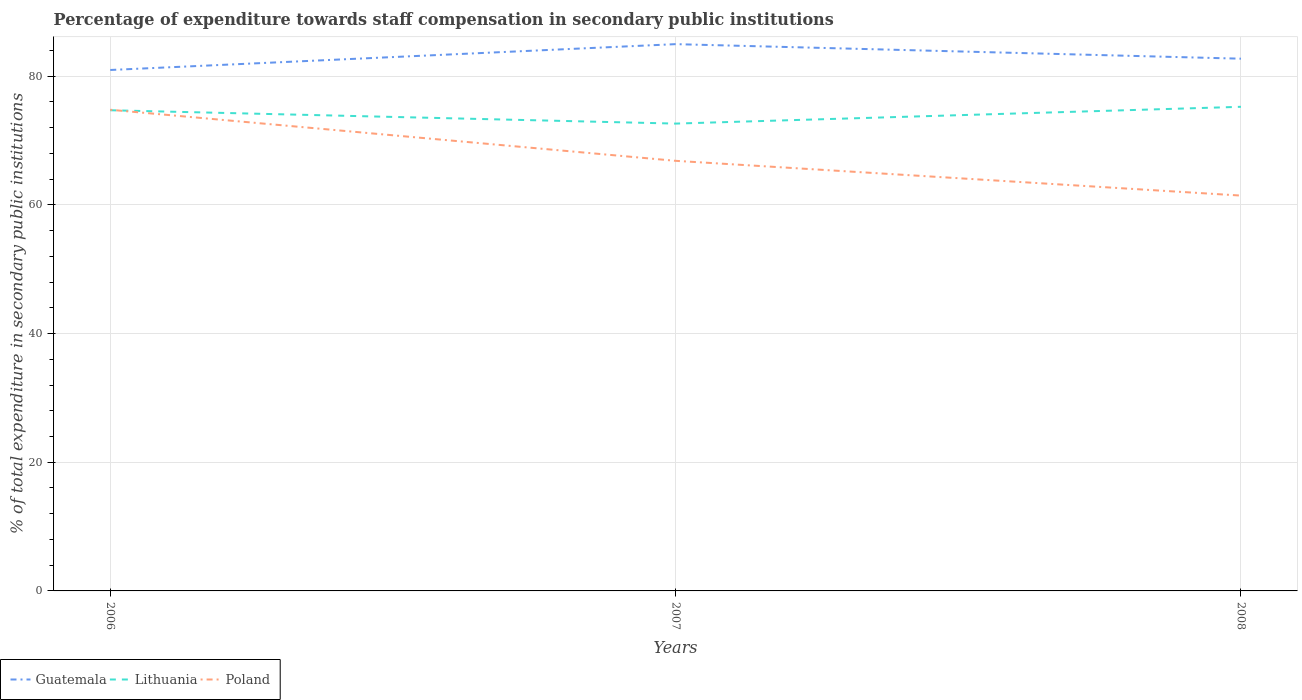Is the number of lines equal to the number of legend labels?
Provide a short and direct response. Yes. Across all years, what is the maximum percentage of expenditure towards staff compensation in Lithuania?
Your response must be concise. 72.64. In which year was the percentage of expenditure towards staff compensation in Guatemala maximum?
Your answer should be compact. 2006. What is the total percentage of expenditure towards staff compensation in Lithuania in the graph?
Your answer should be very brief. -0.54. What is the difference between the highest and the second highest percentage of expenditure towards staff compensation in Poland?
Provide a short and direct response. 13.34. How many lines are there?
Your response must be concise. 3. What is the difference between two consecutive major ticks on the Y-axis?
Give a very brief answer. 20. Are the values on the major ticks of Y-axis written in scientific E-notation?
Your response must be concise. No. Does the graph contain grids?
Offer a terse response. Yes. Where does the legend appear in the graph?
Your answer should be very brief. Bottom left. How many legend labels are there?
Your answer should be compact. 3. What is the title of the graph?
Your response must be concise. Percentage of expenditure towards staff compensation in secondary public institutions. What is the label or title of the X-axis?
Offer a terse response. Years. What is the label or title of the Y-axis?
Provide a succinct answer. % of total expenditure in secondary public institutions. What is the % of total expenditure in secondary public institutions in Guatemala in 2006?
Your answer should be very brief. 80.97. What is the % of total expenditure in secondary public institutions in Lithuania in 2006?
Offer a very short reply. 74.71. What is the % of total expenditure in secondary public institutions in Poland in 2006?
Give a very brief answer. 74.79. What is the % of total expenditure in secondary public institutions of Guatemala in 2007?
Make the answer very short. 84.99. What is the % of total expenditure in secondary public institutions in Lithuania in 2007?
Keep it short and to the point. 72.64. What is the % of total expenditure in secondary public institutions in Poland in 2007?
Offer a very short reply. 66.85. What is the % of total expenditure in secondary public institutions of Guatemala in 2008?
Offer a terse response. 82.73. What is the % of total expenditure in secondary public institutions of Lithuania in 2008?
Your answer should be compact. 75.25. What is the % of total expenditure in secondary public institutions of Poland in 2008?
Offer a terse response. 61.45. Across all years, what is the maximum % of total expenditure in secondary public institutions in Guatemala?
Your answer should be compact. 84.99. Across all years, what is the maximum % of total expenditure in secondary public institutions of Lithuania?
Offer a very short reply. 75.25. Across all years, what is the maximum % of total expenditure in secondary public institutions of Poland?
Your answer should be compact. 74.79. Across all years, what is the minimum % of total expenditure in secondary public institutions in Guatemala?
Give a very brief answer. 80.97. Across all years, what is the minimum % of total expenditure in secondary public institutions of Lithuania?
Offer a very short reply. 72.64. Across all years, what is the minimum % of total expenditure in secondary public institutions of Poland?
Give a very brief answer. 61.45. What is the total % of total expenditure in secondary public institutions of Guatemala in the graph?
Provide a short and direct response. 248.69. What is the total % of total expenditure in secondary public institutions of Lithuania in the graph?
Ensure brevity in your answer.  222.6. What is the total % of total expenditure in secondary public institutions of Poland in the graph?
Make the answer very short. 203.09. What is the difference between the % of total expenditure in secondary public institutions of Guatemala in 2006 and that in 2007?
Keep it short and to the point. -4.02. What is the difference between the % of total expenditure in secondary public institutions of Lithuania in 2006 and that in 2007?
Make the answer very short. 2.07. What is the difference between the % of total expenditure in secondary public institutions in Poland in 2006 and that in 2007?
Offer a terse response. 7.94. What is the difference between the % of total expenditure in secondary public institutions of Guatemala in 2006 and that in 2008?
Ensure brevity in your answer.  -1.76. What is the difference between the % of total expenditure in secondary public institutions of Lithuania in 2006 and that in 2008?
Ensure brevity in your answer.  -0.54. What is the difference between the % of total expenditure in secondary public institutions in Poland in 2006 and that in 2008?
Give a very brief answer. 13.34. What is the difference between the % of total expenditure in secondary public institutions of Guatemala in 2007 and that in 2008?
Your answer should be very brief. 2.26. What is the difference between the % of total expenditure in secondary public institutions in Lithuania in 2007 and that in 2008?
Give a very brief answer. -2.61. What is the difference between the % of total expenditure in secondary public institutions of Poland in 2007 and that in 2008?
Provide a short and direct response. 5.4. What is the difference between the % of total expenditure in secondary public institutions of Guatemala in 2006 and the % of total expenditure in secondary public institutions of Lithuania in 2007?
Provide a short and direct response. 8.33. What is the difference between the % of total expenditure in secondary public institutions in Guatemala in 2006 and the % of total expenditure in secondary public institutions in Poland in 2007?
Offer a very short reply. 14.12. What is the difference between the % of total expenditure in secondary public institutions in Lithuania in 2006 and the % of total expenditure in secondary public institutions in Poland in 2007?
Provide a succinct answer. 7.86. What is the difference between the % of total expenditure in secondary public institutions in Guatemala in 2006 and the % of total expenditure in secondary public institutions in Lithuania in 2008?
Keep it short and to the point. 5.72. What is the difference between the % of total expenditure in secondary public institutions of Guatemala in 2006 and the % of total expenditure in secondary public institutions of Poland in 2008?
Give a very brief answer. 19.52. What is the difference between the % of total expenditure in secondary public institutions in Lithuania in 2006 and the % of total expenditure in secondary public institutions in Poland in 2008?
Keep it short and to the point. 13.26. What is the difference between the % of total expenditure in secondary public institutions of Guatemala in 2007 and the % of total expenditure in secondary public institutions of Lithuania in 2008?
Your answer should be compact. 9.74. What is the difference between the % of total expenditure in secondary public institutions of Guatemala in 2007 and the % of total expenditure in secondary public institutions of Poland in 2008?
Provide a short and direct response. 23.54. What is the difference between the % of total expenditure in secondary public institutions in Lithuania in 2007 and the % of total expenditure in secondary public institutions in Poland in 2008?
Your answer should be compact. 11.19. What is the average % of total expenditure in secondary public institutions in Guatemala per year?
Ensure brevity in your answer.  82.9. What is the average % of total expenditure in secondary public institutions of Lithuania per year?
Ensure brevity in your answer.  74.2. What is the average % of total expenditure in secondary public institutions of Poland per year?
Offer a terse response. 67.7. In the year 2006, what is the difference between the % of total expenditure in secondary public institutions of Guatemala and % of total expenditure in secondary public institutions of Lithuania?
Provide a succinct answer. 6.26. In the year 2006, what is the difference between the % of total expenditure in secondary public institutions of Guatemala and % of total expenditure in secondary public institutions of Poland?
Make the answer very short. 6.18. In the year 2006, what is the difference between the % of total expenditure in secondary public institutions of Lithuania and % of total expenditure in secondary public institutions of Poland?
Your response must be concise. -0.08. In the year 2007, what is the difference between the % of total expenditure in secondary public institutions of Guatemala and % of total expenditure in secondary public institutions of Lithuania?
Your answer should be very brief. 12.35. In the year 2007, what is the difference between the % of total expenditure in secondary public institutions of Guatemala and % of total expenditure in secondary public institutions of Poland?
Give a very brief answer. 18.14. In the year 2007, what is the difference between the % of total expenditure in secondary public institutions in Lithuania and % of total expenditure in secondary public institutions in Poland?
Ensure brevity in your answer.  5.79. In the year 2008, what is the difference between the % of total expenditure in secondary public institutions in Guatemala and % of total expenditure in secondary public institutions in Lithuania?
Make the answer very short. 7.48. In the year 2008, what is the difference between the % of total expenditure in secondary public institutions of Guatemala and % of total expenditure in secondary public institutions of Poland?
Provide a succinct answer. 21.28. In the year 2008, what is the difference between the % of total expenditure in secondary public institutions in Lithuania and % of total expenditure in secondary public institutions in Poland?
Give a very brief answer. 13.8. What is the ratio of the % of total expenditure in secondary public institutions in Guatemala in 2006 to that in 2007?
Your answer should be very brief. 0.95. What is the ratio of the % of total expenditure in secondary public institutions in Lithuania in 2006 to that in 2007?
Offer a terse response. 1.03. What is the ratio of the % of total expenditure in secondary public institutions in Poland in 2006 to that in 2007?
Ensure brevity in your answer.  1.12. What is the ratio of the % of total expenditure in secondary public institutions of Guatemala in 2006 to that in 2008?
Give a very brief answer. 0.98. What is the ratio of the % of total expenditure in secondary public institutions in Lithuania in 2006 to that in 2008?
Your response must be concise. 0.99. What is the ratio of the % of total expenditure in secondary public institutions in Poland in 2006 to that in 2008?
Keep it short and to the point. 1.22. What is the ratio of the % of total expenditure in secondary public institutions of Guatemala in 2007 to that in 2008?
Your answer should be compact. 1.03. What is the ratio of the % of total expenditure in secondary public institutions of Lithuania in 2007 to that in 2008?
Provide a succinct answer. 0.97. What is the ratio of the % of total expenditure in secondary public institutions in Poland in 2007 to that in 2008?
Provide a short and direct response. 1.09. What is the difference between the highest and the second highest % of total expenditure in secondary public institutions of Guatemala?
Provide a succinct answer. 2.26. What is the difference between the highest and the second highest % of total expenditure in secondary public institutions of Lithuania?
Offer a terse response. 0.54. What is the difference between the highest and the second highest % of total expenditure in secondary public institutions in Poland?
Offer a very short reply. 7.94. What is the difference between the highest and the lowest % of total expenditure in secondary public institutions of Guatemala?
Keep it short and to the point. 4.02. What is the difference between the highest and the lowest % of total expenditure in secondary public institutions of Lithuania?
Ensure brevity in your answer.  2.61. What is the difference between the highest and the lowest % of total expenditure in secondary public institutions of Poland?
Make the answer very short. 13.34. 